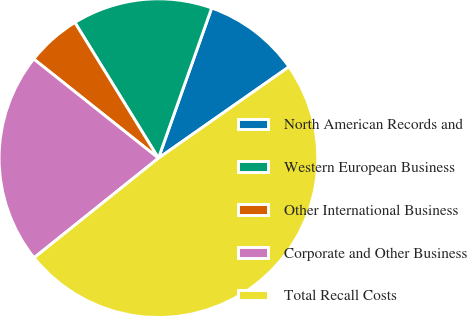Convert chart. <chart><loc_0><loc_0><loc_500><loc_500><pie_chart><fcel>North American Records and<fcel>Western European Business<fcel>Other International Business<fcel>Corporate and Other Business<fcel>Total Recall Costs<nl><fcel>9.86%<fcel>14.21%<fcel>5.52%<fcel>21.44%<fcel>48.97%<nl></chart> 